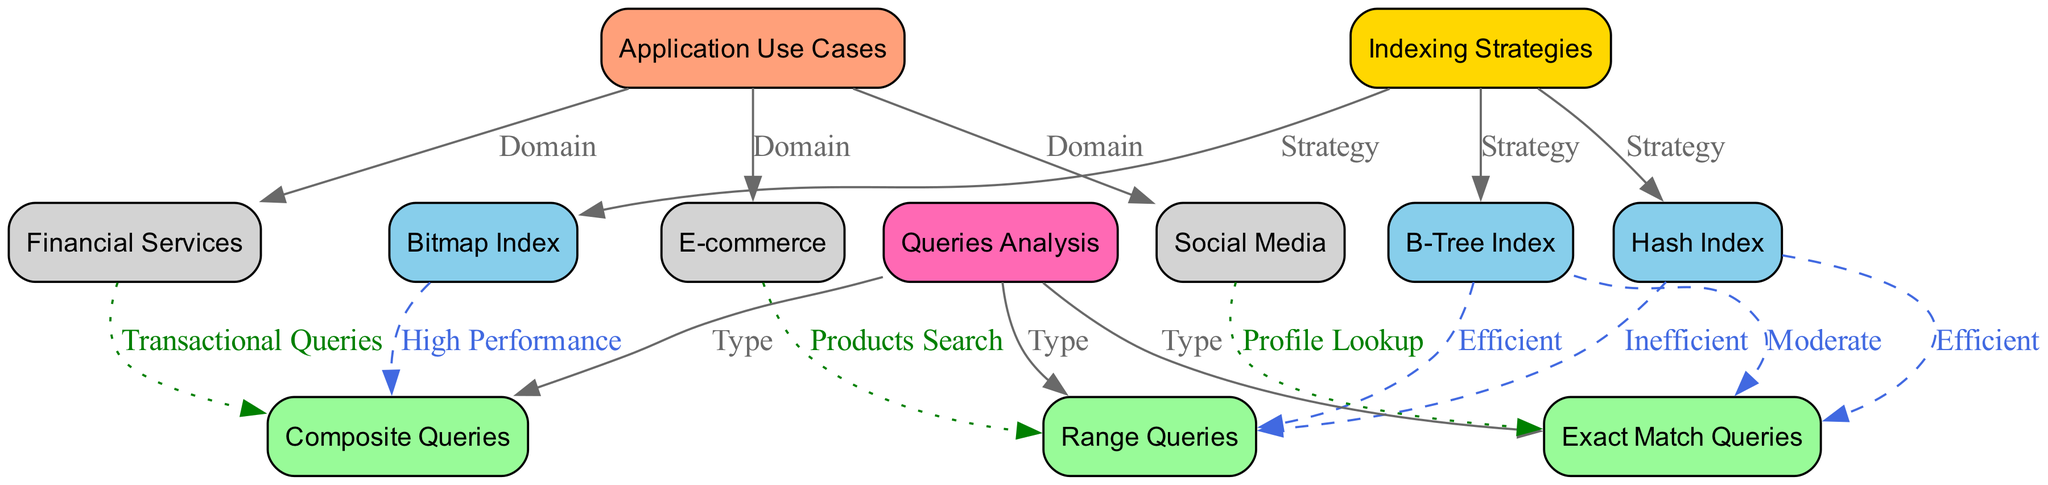What are the three indexing strategies shown in the diagram? The diagram lists three indexing strategies under the "Indexing Strategies" node, which are B-Tree Index, Hash Index, and Bitmap Index.
Answer: B-Tree Index, Hash Index, Bitmap Index Which query type is associated with exact match queries? The diagram shows an edge labeled "Type" connecting "Queries Analysis" to "Exact Match Queries," indicating that exact match queries are one type of query analyzed.
Answer: Exact Match Queries What is the performance impact of B-Tree Index on range queries? The diagram indicates that the B-Tree Index is "Efficient" for range queries, as shown by the edge connecting the B-Tree Index node to the Range Queries node.
Answer: Efficient How many different types of queries are analyzed in the diagram? The diagram includes three types of queries listed under "Queries Analysis": Range Queries, Exact Match Queries, and Composite Queries. By counting these nodes, we see there are three types.
Answer: Three Which application domain is associated with profile lookup queries? The diagram connects "Social Media" to "Exact Match Queries," which indicates that profile lookup queries are typically found in the context of social media applications.
Answer: Social Media What indexing strategy has high performance for composite queries? The diagram shows that the Bitmap Index is linked with "High Performance" for "Composite Queries," indicating its effectiveness in handling these types of queries.
Answer: Bitmap Index How does the performance of Hash Index compare for range queries? The diagram includes an edge from "Hash Index" to "Range Queries" labeled "Inefficient," showing that the Hash Index does not perform well for range queries.
Answer: Inefficient Which application domain relates to products search queries? The diagram clearly connects "E-commerce" with "Range Queries" labeled "Products Search," depicting that the e-commerce domain handles products search queries.
Answer: E-commerce What is the relationship between composite queries and financial services? According to the diagram, "Financial Services" is connected to "Composite Queries" with the label "Transactional Queries," indicating that this domain often involves composite queries in transactional contexts.
Answer: Transactional Queries 